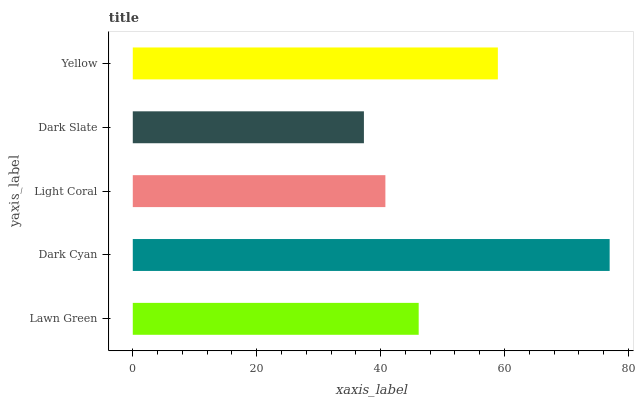Is Dark Slate the minimum?
Answer yes or no. Yes. Is Dark Cyan the maximum?
Answer yes or no. Yes. Is Light Coral the minimum?
Answer yes or no. No. Is Light Coral the maximum?
Answer yes or no. No. Is Dark Cyan greater than Light Coral?
Answer yes or no. Yes. Is Light Coral less than Dark Cyan?
Answer yes or no. Yes. Is Light Coral greater than Dark Cyan?
Answer yes or no. No. Is Dark Cyan less than Light Coral?
Answer yes or no. No. Is Lawn Green the high median?
Answer yes or no. Yes. Is Lawn Green the low median?
Answer yes or no. Yes. Is Dark Cyan the high median?
Answer yes or no. No. Is Dark Cyan the low median?
Answer yes or no. No. 